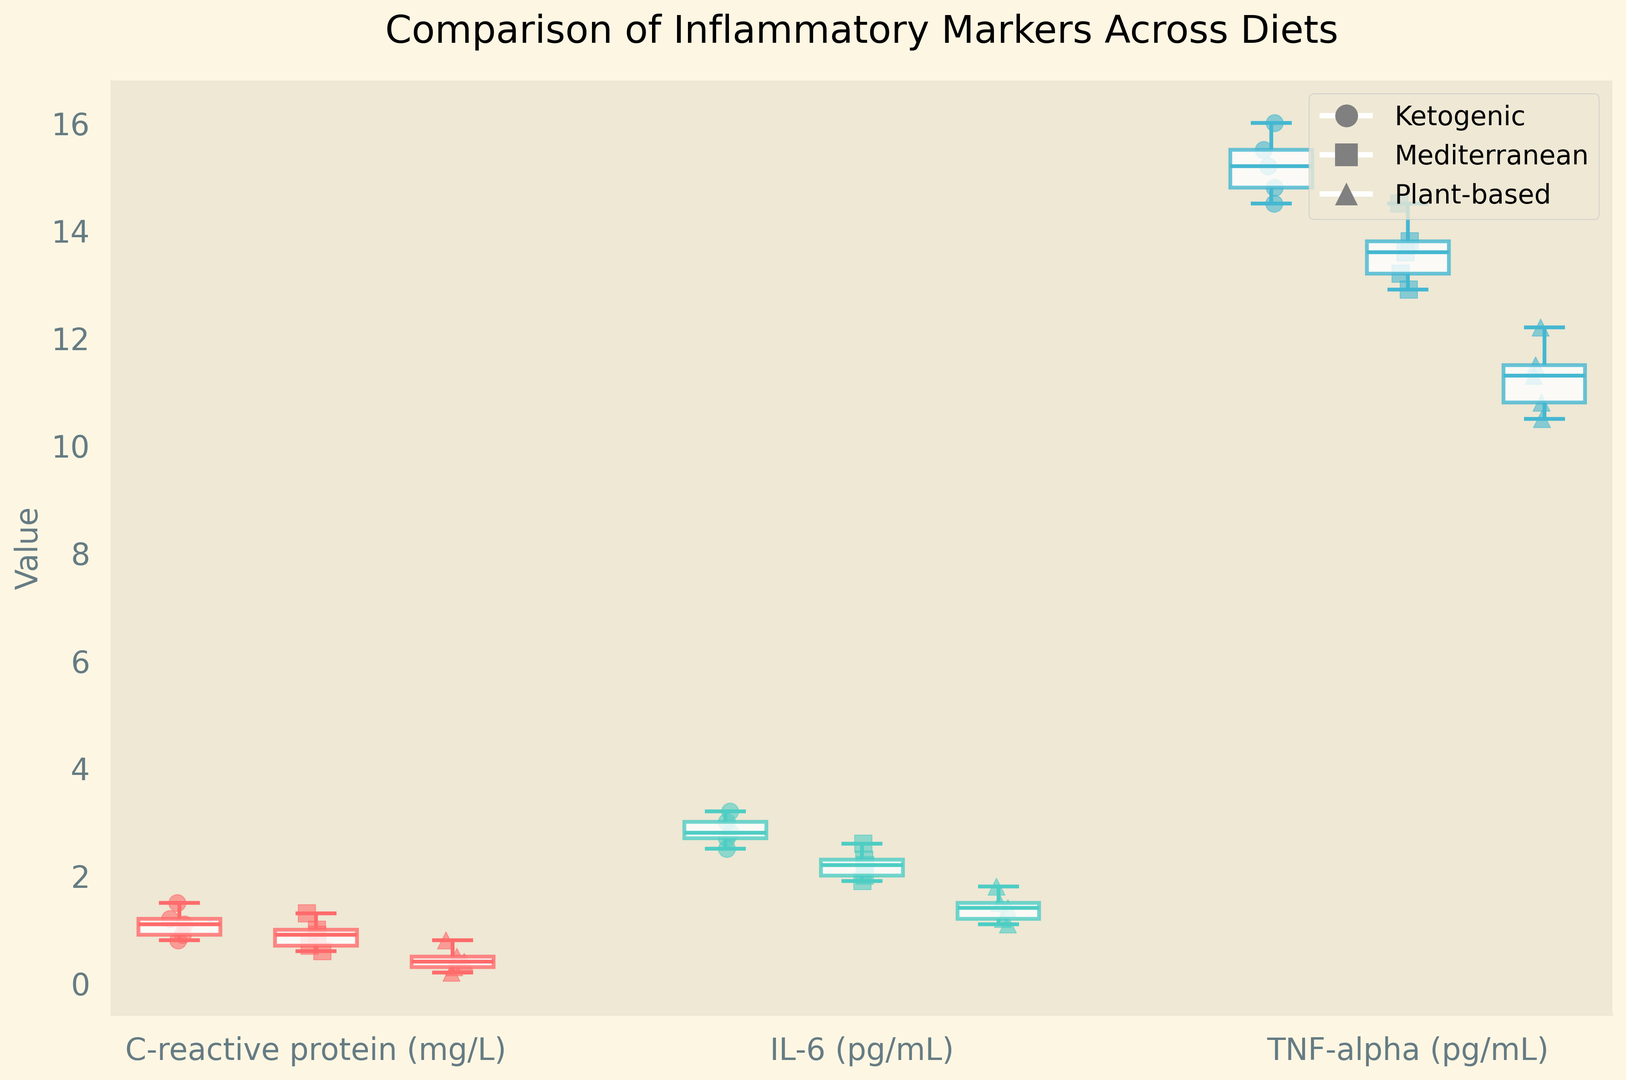Which diet shows the lowest median value for C-reactive protein (mg/L)? To determine this, observe the position of the median line within the boxes for each dietary group under the C-reactive protein (mg/L) category. The plant-based diet shows the lowest position of the median line.
Answer: Plant-based How does the median IL-6 (pg/mL) value for the ketogenic diet compare to the Mediterranean diet? Compare the median lines within the boxes for IL-6 (pg/mL) in the ketogenic and Mediterranean groups. The median for the ketogenic diet is higher than that for the Mediterranean diet.
Answer: Higher What is the difference in the median value of TNF-alpha (pg/mL) between the ketogenic and plant-based diets? Observe the median lines within the boxes under TNF-alpha (pg/mL) for both ketogenic and plant-based diets. Subtract the median of the plant-based group from the median of the ketogenic group.
Answer: 3 Which inflammatory marker shows the smallest overall range of values within the plant-based diet? Look at the length of the whiskers (the lines extending from the boxes) for the plant-based group for each marker. The C-reactive protein (mg/L) has the shortest whiskers, indicating the smallest range.
Answer: C-reactive protein (mg/L) Visualize the spread of data points for TNF-alpha (pg/mL) among the three dietary groups. Which diet exhibits a broader spread? Observe the scatter of individual data points around the boxes for each diet under TNF-alpha (pg/mL). The ketogenic diet has the most widely spread data points.
Answer: Ketogenic For IL-6 (pg/mL), which diet has the greater difference between the first and third quartiles? Assess the height of the boxes (which represent the interquartile range) for each diet under IL-6 (pg/mL). The ketogenic diet has the larger box, indicating a greater difference between the first and third quartiles.
Answer: Ketogenic 